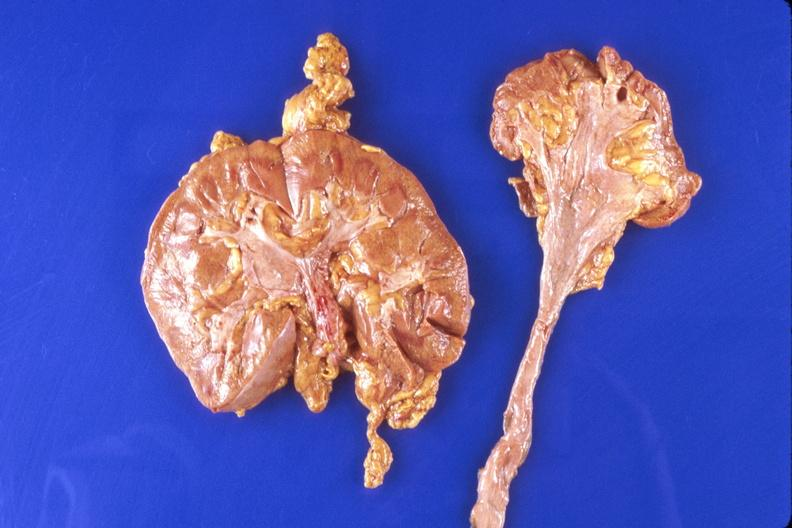what does this image show?
Answer the question using a single word or phrase. Kidney 